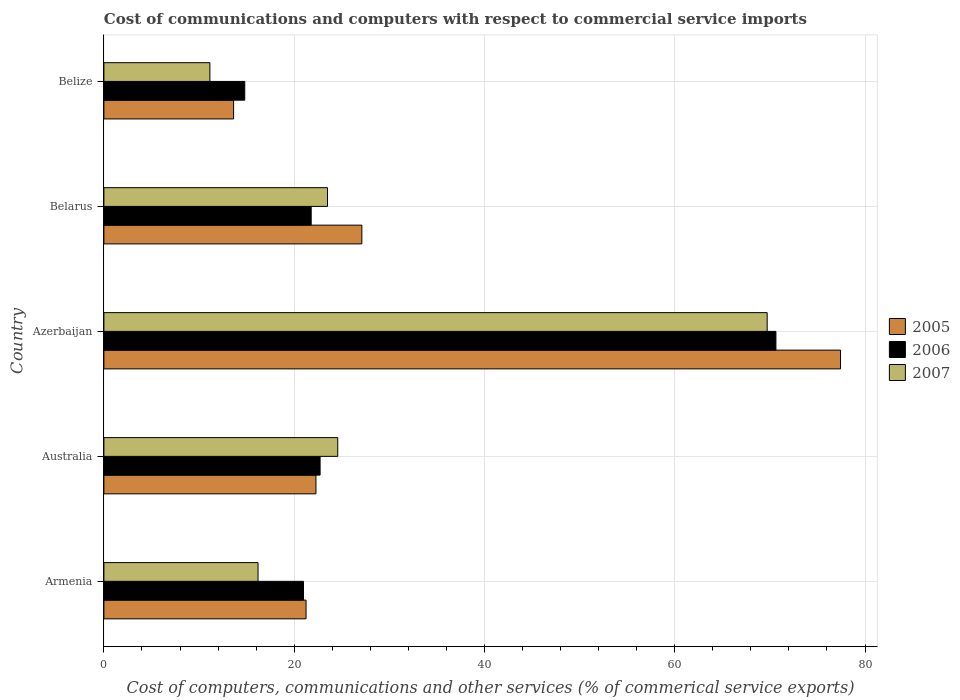How many different coloured bars are there?
Keep it short and to the point. 3. How many groups of bars are there?
Make the answer very short. 5. Are the number of bars on each tick of the Y-axis equal?
Make the answer very short. Yes. What is the label of the 3rd group of bars from the top?
Offer a very short reply. Azerbaijan. In how many cases, is the number of bars for a given country not equal to the number of legend labels?
Provide a short and direct response. 0. What is the cost of communications and computers in 2007 in Australia?
Give a very brief answer. 24.58. Across all countries, what is the maximum cost of communications and computers in 2005?
Make the answer very short. 77.43. Across all countries, what is the minimum cost of communications and computers in 2007?
Make the answer very short. 11.14. In which country was the cost of communications and computers in 2006 maximum?
Your answer should be very brief. Azerbaijan. In which country was the cost of communications and computers in 2005 minimum?
Give a very brief answer. Belize. What is the total cost of communications and computers in 2007 in the graph?
Keep it short and to the point. 145.14. What is the difference between the cost of communications and computers in 2007 in Armenia and that in Australia?
Offer a very short reply. -8.38. What is the difference between the cost of communications and computers in 2007 in Armenia and the cost of communications and computers in 2005 in Azerbaijan?
Give a very brief answer. -61.23. What is the average cost of communications and computers in 2006 per country?
Ensure brevity in your answer.  30.19. What is the difference between the cost of communications and computers in 2006 and cost of communications and computers in 2005 in Belize?
Your answer should be compact. 1.17. In how many countries, is the cost of communications and computers in 2005 greater than 24 %?
Your answer should be compact. 2. What is the ratio of the cost of communications and computers in 2007 in Azerbaijan to that in Belize?
Your answer should be very brief. 6.26. Is the cost of communications and computers in 2007 in Belarus less than that in Belize?
Your response must be concise. No. What is the difference between the highest and the second highest cost of communications and computers in 2006?
Offer a very short reply. 47.91. What is the difference between the highest and the lowest cost of communications and computers in 2006?
Offer a very short reply. 55.83. Is the sum of the cost of communications and computers in 2007 in Belarus and Belize greater than the maximum cost of communications and computers in 2005 across all countries?
Provide a succinct answer. No. What does the 3rd bar from the top in Azerbaijan represents?
Ensure brevity in your answer.  2005. What does the 1st bar from the bottom in Australia represents?
Give a very brief answer. 2005. Are the values on the major ticks of X-axis written in scientific E-notation?
Your answer should be compact. No. Does the graph contain any zero values?
Your response must be concise. No. How many legend labels are there?
Ensure brevity in your answer.  3. How are the legend labels stacked?
Provide a short and direct response. Vertical. What is the title of the graph?
Ensure brevity in your answer.  Cost of communications and computers with respect to commercial service imports. What is the label or title of the X-axis?
Your answer should be very brief. Cost of computers, communications and other services (% of commerical service exports). What is the label or title of the Y-axis?
Offer a very short reply. Country. What is the Cost of computers, communications and other services (% of commerical service exports) of 2005 in Armenia?
Ensure brevity in your answer.  21.25. What is the Cost of computers, communications and other services (% of commerical service exports) of 2006 in Armenia?
Your response must be concise. 20.98. What is the Cost of computers, communications and other services (% of commerical service exports) in 2007 in Armenia?
Your answer should be very brief. 16.2. What is the Cost of computers, communications and other services (% of commerical service exports) of 2005 in Australia?
Your response must be concise. 22.29. What is the Cost of computers, communications and other services (% of commerical service exports) of 2006 in Australia?
Provide a succinct answer. 22.72. What is the Cost of computers, communications and other services (% of commerical service exports) in 2007 in Australia?
Offer a very short reply. 24.58. What is the Cost of computers, communications and other services (% of commerical service exports) of 2005 in Azerbaijan?
Give a very brief answer. 77.43. What is the Cost of computers, communications and other services (% of commerical service exports) in 2006 in Azerbaijan?
Ensure brevity in your answer.  70.64. What is the Cost of computers, communications and other services (% of commerical service exports) of 2007 in Azerbaijan?
Ensure brevity in your answer.  69.72. What is the Cost of computers, communications and other services (% of commerical service exports) of 2005 in Belarus?
Keep it short and to the point. 27.11. What is the Cost of computers, communications and other services (% of commerical service exports) of 2006 in Belarus?
Offer a very short reply. 21.79. What is the Cost of computers, communications and other services (% of commerical service exports) in 2007 in Belarus?
Ensure brevity in your answer.  23.5. What is the Cost of computers, communications and other services (% of commerical service exports) in 2005 in Belize?
Provide a succinct answer. 13.63. What is the Cost of computers, communications and other services (% of commerical service exports) of 2006 in Belize?
Your answer should be very brief. 14.8. What is the Cost of computers, communications and other services (% of commerical service exports) in 2007 in Belize?
Offer a terse response. 11.14. Across all countries, what is the maximum Cost of computers, communications and other services (% of commerical service exports) in 2005?
Ensure brevity in your answer.  77.43. Across all countries, what is the maximum Cost of computers, communications and other services (% of commerical service exports) of 2006?
Offer a terse response. 70.64. Across all countries, what is the maximum Cost of computers, communications and other services (% of commerical service exports) of 2007?
Your answer should be compact. 69.72. Across all countries, what is the minimum Cost of computers, communications and other services (% of commerical service exports) in 2005?
Ensure brevity in your answer.  13.63. Across all countries, what is the minimum Cost of computers, communications and other services (% of commerical service exports) in 2006?
Ensure brevity in your answer.  14.8. Across all countries, what is the minimum Cost of computers, communications and other services (% of commerical service exports) of 2007?
Keep it short and to the point. 11.14. What is the total Cost of computers, communications and other services (% of commerical service exports) of 2005 in the graph?
Give a very brief answer. 161.71. What is the total Cost of computers, communications and other services (% of commerical service exports) in 2006 in the graph?
Your response must be concise. 150.93. What is the total Cost of computers, communications and other services (% of commerical service exports) in 2007 in the graph?
Your answer should be very brief. 145.14. What is the difference between the Cost of computers, communications and other services (% of commerical service exports) in 2005 in Armenia and that in Australia?
Your response must be concise. -1.04. What is the difference between the Cost of computers, communications and other services (% of commerical service exports) in 2006 in Armenia and that in Australia?
Provide a short and direct response. -1.74. What is the difference between the Cost of computers, communications and other services (% of commerical service exports) in 2007 in Armenia and that in Australia?
Provide a succinct answer. -8.38. What is the difference between the Cost of computers, communications and other services (% of commerical service exports) of 2005 in Armenia and that in Azerbaijan?
Give a very brief answer. -56.18. What is the difference between the Cost of computers, communications and other services (% of commerical service exports) in 2006 in Armenia and that in Azerbaijan?
Give a very brief answer. -49.66. What is the difference between the Cost of computers, communications and other services (% of commerical service exports) in 2007 in Armenia and that in Azerbaijan?
Your answer should be compact. -53.52. What is the difference between the Cost of computers, communications and other services (% of commerical service exports) of 2005 in Armenia and that in Belarus?
Make the answer very short. -5.87. What is the difference between the Cost of computers, communications and other services (% of commerical service exports) in 2006 in Armenia and that in Belarus?
Your response must be concise. -0.81. What is the difference between the Cost of computers, communications and other services (% of commerical service exports) of 2007 in Armenia and that in Belarus?
Your response must be concise. -7.3. What is the difference between the Cost of computers, communications and other services (% of commerical service exports) in 2005 in Armenia and that in Belize?
Your answer should be compact. 7.62. What is the difference between the Cost of computers, communications and other services (% of commerical service exports) in 2006 in Armenia and that in Belize?
Ensure brevity in your answer.  6.18. What is the difference between the Cost of computers, communications and other services (% of commerical service exports) in 2007 in Armenia and that in Belize?
Keep it short and to the point. 5.06. What is the difference between the Cost of computers, communications and other services (% of commerical service exports) in 2005 in Australia and that in Azerbaijan?
Offer a terse response. -55.14. What is the difference between the Cost of computers, communications and other services (% of commerical service exports) in 2006 in Australia and that in Azerbaijan?
Your response must be concise. -47.91. What is the difference between the Cost of computers, communications and other services (% of commerical service exports) in 2007 in Australia and that in Azerbaijan?
Keep it short and to the point. -45.14. What is the difference between the Cost of computers, communications and other services (% of commerical service exports) of 2005 in Australia and that in Belarus?
Keep it short and to the point. -4.83. What is the difference between the Cost of computers, communications and other services (% of commerical service exports) in 2006 in Australia and that in Belarus?
Your response must be concise. 0.94. What is the difference between the Cost of computers, communications and other services (% of commerical service exports) of 2007 in Australia and that in Belarus?
Keep it short and to the point. 1.07. What is the difference between the Cost of computers, communications and other services (% of commerical service exports) in 2005 in Australia and that in Belize?
Provide a succinct answer. 8.66. What is the difference between the Cost of computers, communications and other services (% of commerical service exports) of 2006 in Australia and that in Belize?
Offer a very short reply. 7.92. What is the difference between the Cost of computers, communications and other services (% of commerical service exports) of 2007 in Australia and that in Belize?
Provide a short and direct response. 13.44. What is the difference between the Cost of computers, communications and other services (% of commerical service exports) in 2005 in Azerbaijan and that in Belarus?
Provide a short and direct response. 50.31. What is the difference between the Cost of computers, communications and other services (% of commerical service exports) in 2006 in Azerbaijan and that in Belarus?
Make the answer very short. 48.85. What is the difference between the Cost of computers, communications and other services (% of commerical service exports) of 2007 in Azerbaijan and that in Belarus?
Offer a very short reply. 46.21. What is the difference between the Cost of computers, communications and other services (% of commerical service exports) of 2005 in Azerbaijan and that in Belize?
Provide a succinct answer. 63.8. What is the difference between the Cost of computers, communications and other services (% of commerical service exports) of 2006 in Azerbaijan and that in Belize?
Provide a short and direct response. 55.83. What is the difference between the Cost of computers, communications and other services (% of commerical service exports) of 2007 in Azerbaijan and that in Belize?
Provide a succinct answer. 58.57. What is the difference between the Cost of computers, communications and other services (% of commerical service exports) in 2005 in Belarus and that in Belize?
Offer a very short reply. 13.48. What is the difference between the Cost of computers, communications and other services (% of commerical service exports) of 2006 in Belarus and that in Belize?
Offer a terse response. 6.98. What is the difference between the Cost of computers, communications and other services (% of commerical service exports) in 2007 in Belarus and that in Belize?
Make the answer very short. 12.36. What is the difference between the Cost of computers, communications and other services (% of commerical service exports) of 2005 in Armenia and the Cost of computers, communications and other services (% of commerical service exports) of 2006 in Australia?
Offer a terse response. -1.48. What is the difference between the Cost of computers, communications and other services (% of commerical service exports) of 2005 in Armenia and the Cost of computers, communications and other services (% of commerical service exports) of 2007 in Australia?
Offer a terse response. -3.33. What is the difference between the Cost of computers, communications and other services (% of commerical service exports) of 2006 in Armenia and the Cost of computers, communications and other services (% of commerical service exports) of 2007 in Australia?
Offer a very short reply. -3.6. What is the difference between the Cost of computers, communications and other services (% of commerical service exports) in 2005 in Armenia and the Cost of computers, communications and other services (% of commerical service exports) in 2006 in Azerbaijan?
Ensure brevity in your answer.  -49.39. What is the difference between the Cost of computers, communications and other services (% of commerical service exports) in 2005 in Armenia and the Cost of computers, communications and other services (% of commerical service exports) in 2007 in Azerbaijan?
Your answer should be very brief. -48.47. What is the difference between the Cost of computers, communications and other services (% of commerical service exports) of 2006 in Armenia and the Cost of computers, communications and other services (% of commerical service exports) of 2007 in Azerbaijan?
Offer a very short reply. -48.74. What is the difference between the Cost of computers, communications and other services (% of commerical service exports) of 2005 in Armenia and the Cost of computers, communications and other services (% of commerical service exports) of 2006 in Belarus?
Offer a very short reply. -0.54. What is the difference between the Cost of computers, communications and other services (% of commerical service exports) of 2005 in Armenia and the Cost of computers, communications and other services (% of commerical service exports) of 2007 in Belarus?
Keep it short and to the point. -2.26. What is the difference between the Cost of computers, communications and other services (% of commerical service exports) of 2006 in Armenia and the Cost of computers, communications and other services (% of commerical service exports) of 2007 in Belarus?
Keep it short and to the point. -2.52. What is the difference between the Cost of computers, communications and other services (% of commerical service exports) in 2005 in Armenia and the Cost of computers, communications and other services (% of commerical service exports) in 2006 in Belize?
Your response must be concise. 6.44. What is the difference between the Cost of computers, communications and other services (% of commerical service exports) of 2005 in Armenia and the Cost of computers, communications and other services (% of commerical service exports) of 2007 in Belize?
Keep it short and to the point. 10.11. What is the difference between the Cost of computers, communications and other services (% of commerical service exports) of 2006 in Armenia and the Cost of computers, communications and other services (% of commerical service exports) of 2007 in Belize?
Offer a very short reply. 9.84. What is the difference between the Cost of computers, communications and other services (% of commerical service exports) of 2005 in Australia and the Cost of computers, communications and other services (% of commerical service exports) of 2006 in Azerbaijan?
Your answer should be very brief. -48.35. What is the difference between the Cost of computers, communications and other services (% of commerical service exports) in 2005 in Australia and the Cost of computers, communications and other services (% of commerical service exports) in 2007 in Azerbaijan?
Provide a short and direct response. -47.43. What is the difference between the Cost of computers, communications and other services (% of commerical service exports) in 2006 in Australia and the Cost of computers, communications and other services (% of commerical service exports) in 2007 in Azerbaijan?
Provide a succinct answer. -46.99. What is the difference between the Cost of computers, communications and other services (% of commerical service exports) of 2005 in Australia and the Cost of computers, communications and other services (% of commerical service exports) of 2006 in Belarus?
Keep it short and to the point. 0.5. What is the difference between the Cost of computers, communications and other services (% of commerical service exports) in 2005 in Australia and the Cost of computers, communications and other services (% of commerical service exports) in 2007 in Belarus?
Your answer should be very brief. -1.22. What is the difference between the Cost of computers, communications and other services (% of commerical service exports) of 2006 in Australia and the Cost of computers, communications and other services (% of commerical service exports) of 2007 in Belarus?
Give a very brief answer. -0.78. What is the difference between the Cost of computers, communications and other services (% of commerical service exports) of 2005 in Australia and the Cost of computers, communications and other services (% of commerical service exports) of 2006 in Belize?
Give a very brief answer. 7.48. What is the difference between the Cost of computers, communications and other services (% of commerical service exports) in 2005 in Australia and the Cost of computers, communications and other services (% of commerical service exports) in 2007 in Belize?
Your response must be concise. 11.15. What is the difference between the Cost of computers, communications and other services (% of commerical service exports) in 2006 in Australia and the Cost of computers, communications and other services (% of commerical service exports) in 2007 in Belize?
Offer a terse response. 11.58. What is the difference between the Cost of computers, communications and other services (% of commerical service exports) of 2005 in Azerbaijan and the Cost of computers, communications and other services (% of commerical service exports) of 2006 in Belarus?
Ensure brevity in your answer.  55.64. What is the difference between the Cost of computers, communications and other services (% of commerical service exports) in 2005 in Azerbaijan and the Cost of computers, communications and other services (% of commerical service exports) in 2007 in Belarus?
Provide a succinct answer. 53.92. What is the difference between the Cost of computers, communications and other services (% of commerical service exports) in 2006 in Azerbaijan and the Cost of computers, communications and other services (% of commerical service exports) in 2007 in Belarus?
Offer a very short reply. 47.13. What is the difference between the Cost of computers, communications and other services (% of commerical service exports) in 2005 in Azerbaijan and the Cost of computers, communications and other services (% of commerical service exports) in 2006 in Belize?
Your answer should be very brief. 62.62. What is the difference between the Cost of computers, communications and other services (% of commerical service exports) in 2005 in Azerbaijan and the Cost of computers, communications and other services (% of commerical service exports) in 2007 in Belize?
Your response must be concise. 66.29. What is the difference between the Cost of computers, communications and other services (% of commerical service exports) in 2006 in Azerbaijan and the Cost of computers, communications and other services (% of commerical service exports) in 2007 in Belize?
Your answer should be very brief. 59.49. What is the difference between the Cost of computers, communications and other services (% of commerical service exports) of 2005 in Belarus and the Cost of computers, communications and other services (% of commerical service exports) of 2006 in Belize?
Your answer should be very brief. 12.31. What is the difference between the Cost of computers, communications and other services (% of commerical service exports) in 2005 in Belarus and the Cost of computers, communications and other services (% of commerical service exports) in 2007 in Belize?
Give a very brief answer. 15.97. What is the difference between the Cost of computers, communications and other services (% of commerical service exports) of 2006 in Belarus and the Cost of computers, communications and other services (% of commerical service exports) of 2007 in Belize?
Provide a short and direct response. 10.65. What is the average Cost of computers, communications and other services (% of commerical service exports) of 2005 per country?
Keep it short and to the point. 32.34. What is the average Cost of computers, communications and other services (% of commerical service exports) in 2006 per country?
Give a very brief answer. 30.19. What is the average Cost of computers, communications and other services (% of commerical service exports) of 2007 per country?
Your answer should be compact. 29.03. What is the difference between the Cost of computers, communications and other services (% of commerical service exports) in 2005 and Cost of computers, communications and other services (% of commerical service exports) in 2006 in Armenia?
Offer a very short reply. 0.27. What is the difference between the Cost of computers, communications and other services (% of commerical service exports) of 2005 and Cost of computers, communications and other services (% of commerical service exports) of 2007 in Armenia?
Keep it short and to the point. 5.05. What is the difference between the Cost of computers, communications and other services (% of commerical service exports) of 2006 and Cost of computers, communications and other services (% of commerical service exports) of 2007 in Armenia?
Offer a terse response. 4.78. What is the difference between the Cost of computers, communications and other services (% of commerical service exports) of 2005 and Cost of computers, communications and other services (% of commerical service exports) of 2006 in Australia?
Keep it short and to the point. -0.44. What is the difference between the Cost of computers, communications and other services (% of commerical service exports) in 2005 and Cost of computers, communications and other services (% of commerical service exports) in 2007 in Australia?
Provide a succinct answer. -2.29. What is the difference between the Cost of computers, communications and other services (% of commerical service exports) of 2006 and Cost of computers, communications and other services (% of commerical service exports) of 2007 in Australia?
Provide a succinct answer. -1.85. What is the difference between the Cost of computers, communications and other services (% of commerical service exports) of 2005 and Cost of computers, communications and other services (% of commerical service exports) of 2006 in Azerbaijan?
Your answer should be compact. 6.79. What is the difference between the Cost of computers, communications and other services (% of commerical service exports) of 2005 and Cost of computers, communications and other services (% of commerical service exports) of 2007 in Azerbaijan?
Keep it short and to the point. 7.71. What is the difference between the Cost of computers, communications and other services (% of commerical service exports) of 2006 and Cost of computers, communications and other services (% of commerical service exports) of 2007 in Azerbaijan?
Give a very brief answer. 0.92. What is the difference between the Cost of computers, communications and other services (% of commerical service exports) in 2005 and Cost of computers, communications and other services (% of commerical service exports) in 2006 in Belarus?
Provide a succinct answer. 5.33. What is the difference between the Cost of computers, communications and other services (% of commerical service exports) of 2005 and Cost of computers, communications and other services (% of commerical service exports) of 2007 in Belarus?
Your answer should be very brief. 3.61. What is the difference between the Cost of computers, communications and other services (% of commerical service exports) in 2006 and Cost of computers, communications and other services (% of commerical service exports) in 2007 in Belarus?
Keep it short and to the point. -1.72. What is the difference between the Cost of computers, communications and other services (% of commerical service exports) in 2005 and Cost of computers, communications and other services (% of commerical service exports) in 2006 in Belize?
Offer a terse response. -1.17. What is the difference between the Cost of computers, communications and other services (% of commerical service exports) in 2005 and Cost of computers, communications and other services (% of commerical service exports) in 2007 in Belize?
Provide a short and direct response. 2.49. What is the difference between the Cost of computers, communications and other services (% of commerical service exports) of 2006 and Cost of computers, communications and other services (% of commerical service exports) of 2007 in Belize?
Offer a terse response. 3.66. What is the ratio of the Cost of computers, communications and other services (% of commerical service exports) of 2005 in Armenia to that in Australia?
Ensure brevity in your answer.  0.95. What is the ratio of the Cost of computers, communications and other services (% of commerical service exports) of 2006 in Armenia to that in Australia?
Your answer should be compact. 0.92. What is the ratio of the Cost of computers, communications and other services (% of commerical service exports) in 2007 in Armenia to that in Australia?
Make the answer very short. 0.66. What is the ratio of the Cost of computers, communications and other services (% of commerical service exports) in 2005 in Armenia to that in Azerbaijan?
Keep it short and to the point. 0.27. What is the ratio of the Cost of computers, communications and other services (% of commerical service exports) of 2006 in Armenia to that in Azerbaijan?
Give a very brief answer. 0.3. What is the ratio of the Cost of computers, communications and other services (% of commerical service exports) in 2007 in Armenia to that in Azerbaijan?
Make the answer very short. 0.23. What is the ratio of the Cost of computers, communications and other services (% of commerical service exports) of 2005 in Armenia to that in Belarus?
Offer a very short reply. 0.78. What is the ratio of the Cost of computers, communications and other services (% of commerical service exports) in 2006 in Armenia to that in Belarus?
Give a very brief answer. 0.96. What is the ratio of the Cost of computers, communications and other services (% of commerical service exports) of 2007 in Armenia to that in Belarus?
Your answer should be very brief. 0.69. What is the ratio of the Cost of computers, communications and other services (% of commerical service exports) of 2005 in Armenia to that in Belize?
Keep it short and to the point. 1.56. What is the ratio of the Cost of computers, communications and other services (% of commerical service exports) in 2006 in Armenia to that in Belize?
Your response must be concise. 1.42. What is the ratio of the Cost of computers, communications and other services (% of commerical service exports) in 2007 in Armenia to that in Belize?
Make the answer very short. 1.45. What is the ratio of the Cost of computers, communications and other services (% of commerical service exports) of 2005 in Australia to that in Azerbaijan?
Give a very brief answer. 0.29. What is the ratio of the Cost of computers, communications and other services (% of commerical service exports) of 2006 in Australia to that in Azerbaijan?
Provide a succinct answer. 0.32. What is the ratio of the Cost of computers, communications and other services (% of commerical service exports) of 2007 in Australia to that in Azerbaijan?
Provide a succinct answer. 0.35. What is the ratio of the Cost of computers, communications and other services (% of commerical service exports) in 2005 in Australia to that in Belarus?
Keep it short and to the point. 0.82. What is the ratio of the Cost of computers, communications and other services (% of commerical service exports) in 2006 in Australia to that in Belarus?
Keep it short and to the point. 1.04. What is the ratio of the Cost of computers, communications and other services (% of commerical service exports) of 2007 in Australia to that in Belarus?
Your answer should be compact. 1.05. What is the ratio of the Cost of computers, communications and other services (% of commerical service exports) in 2005 in Australia to that in Belize?
Your answer should be very brief. 1.64. What is the ratio of the Cost of computers, communications and other services (% of commerical service exports) in 2006 in Australia to that in Belize?
Offer a terse response. 1.53. What is the ratio of the Cost of computers, communications and other services (% of commerical service exports) of 2007 in Australia to that in Belize?
Your response must be concise. 2.21. What is the ratio of the Cost of computers, communications and other services (% of commerical service exports) in 2005 in Azerbaijan to that in Belarus?
Give a very brief answer. 2.86. What is the ratio of the Cost of computers, communications and other services (% of commerical service exports) of 2006 in Azerbaijan to that in Belarus?
Keep it short and to the point. 3.24. What is the ratio of the Cost of computers, communications and other services (% of commerical service exports) of 2007 in Azerbaijan to that in Belarus?
Your answer should be very brief. 2.97. What is the ratio of the Cost of computers, communications and other services (% of commerical service exports) in 2005 in Azerbaijan to that in Belize?
Offer a very short reply. 5.68. What is the ratio of the Cost of computers, communications and other services (% of commerical service exports) of 2006 in Azerbaijan to that in Belize?
Provide a succinct answer. 4.77. What is the ratio of the Cost of computers, communications and other services (% of commerical service exports) in 2007 in Azerbaijan to that in Belize?
Your response must be concise. 6.26. What is the ratio of the Cost of computers, communications and other services (% of commerical service exports) in 2005 in Belarus to that in Belize?
Your response must be concise. 1.99. What is the ratio of the Cost of computers, communications and other services (% of commerical service exports) in 2006 in Belarus to that in Belize?
Give a very brief answer. 1.47. What is the ratio of the Cost of computers, communications and other services (% of commerical service exports) of 2007 in Belarus to that in Belize?
Make the answer very short. 2.11. What is the difference between the highest and the second highest Cost of computers, communications and other services (% of commerical service exports) of 2005?
Provide a succinct answer. 50.31. What is the difference between the highest and the second highest Cost of computers, communications and other services (% of commerical service exports) in 2006?
Your response must be concise. 47.91. What is the difference between the highest and the second highest Cost of computers, communications and other services (% of commerical service exports) in 2007?
Your response must be concise. 45.14. What is the difference between the highest and the lowest Cost of computers, communications and other services (% of commerical service exports) in 2005?
Offer a very short reply. 63.8. What is the difference between the highest and the lowest Cost of computers, communications and other services (% of commerical service exports) of 2006?
Your answer should be very brief. 55.83. What is the difference between the highest and the lowest Cost of computers, communications and other services (% of commerical service exports) in 2007?
Your answer should be compact. 58.57. 